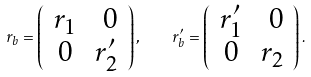Convert formula to latex. <formula><loc_0><loc_0><loc_500><loc_500>r _ { b } = \left ( \begin{array} { c r } r _ { 1 } & 0 \\ 0 & r _ { 2 } ^ { \prime } \end{array} \right ) , \quad r _ { b } ^ { \prime } = \left ( \begin{array} { c r } r _ { 1 } ^ { \prime } & 0 \\ 0 & r _ { 2 } \end{array} \right ) .</formula> 